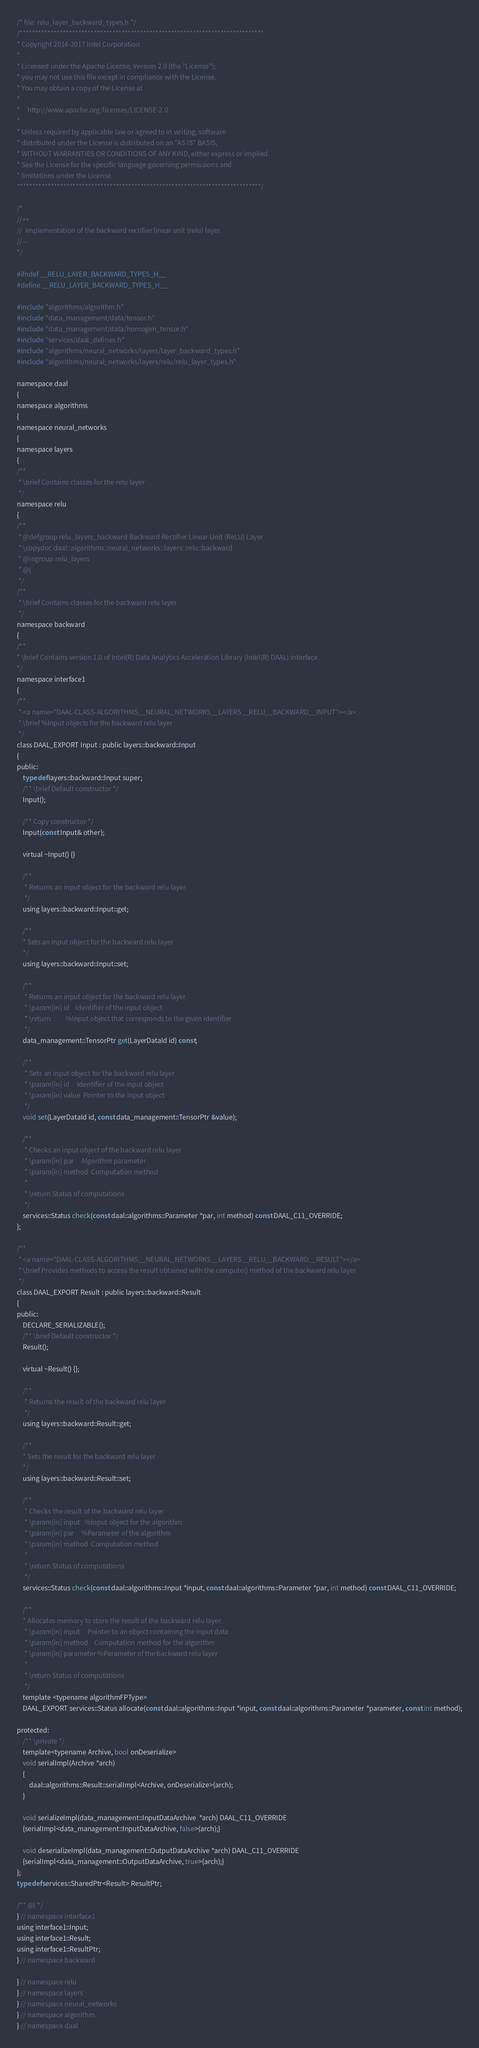<code> <loc_0><loc_0><loc_500><loc_500><_C_>/* file: relu_layer_backward_types.h */
/*******************************************************************************
* Copyright 2014-2017 Intel Corporation
*
* Licensed under the Apache License, Version 2.0 (the "License");
* you may not use this file except in compliance with the License.
* You may obtain a copy of the License at
*
*     http://www.apache.org/licenses/LICENSE-2.0
*
* Unless required by applicable law or agreed to in writing, software
* distributed under the License is distributed on an "AS IS" BASIS,
* WITHOUT WARRANTIES OR CONDITIONS OF ANY KIND, either express or implied.
* See the License for the specific language governing permissions and
* limitations under the License.
*******************************************************************************/

/*
//++
//  Implementation of the backward rectifier linear unit (relu) layer.
//--
*/

#ifndef __RELU_LAYER_BACKWARD_TYPES_H__
#define __RELU_LAYER_BACKWARD_TYPES_H__

#include "algorithms/algorithm.h"
#include "data_management/data/tensor.h"
#include "data_management/data/homogen_tensor.h"
#include "services/daal_defines.h"
#include "algorithms/neural_networks/layers/layer_backward_types.h"
#include "algorithms/neural_networks/layers/relu/relu_layer_types.h"

namespace daal
{
namespace algorithms
{
namespace neural_networks
{
namespace layers
{
/**
 * \brief Contains classes for the relu layer
 */
namespace relu
{
/**
 * @defgroup relu_layers_backward Backward Rectifier Linear Unit (ReLU) Layer
 * \copydoc daal::algorithms::neural_networks::layers::relu::backward
 * @ingroup relu_layers
 * @{
 */
/**
 * \brief Contains classes for the backward relu layer
 */
namespace backward
{
/**
* \brief Contains version 1.0 of Intel(R) Data Analytics Acceleration Library (Intel(R) DAAL) interface.
*/
namespace interface1
{
/**
 * <a name="DAAL-CLASS-ALGORITHMS__NEURAL_NETWORKS__LAYERS__RELU__BACKWARD__INPUT"></a>
 * \brief %Input objects for the backward relu layer
 */
class DAAL_EXPORT Input : public layers::backward::Input
{
public:
    typedef layers::backward::Input super;
    /** \brief Default constructor */
    Input();

    /** Copy constructor */
    Input(const Input& other);

    virtual ~Input() {}

    /**
     * Returns an input object for the backward relu layer
     */
    using layers::backward::Input::get;

    /**
    * Sets an input object for the backward relu layer
    */
    using layers::backward::Input::set;

    /**
     * Returns an input object for the backward relu layer
     * \param[in] id    Identifier of the input object
     * \return          %Input object that corresponds to the given identifier
     */
    data_management::TensorPtr get(LayerDataId id) const;

    /**
     * Sets an input object for the backward relu layer
     * \param[in] id     Identifier of the input object
     * \param[in] value  Pointer to the input object
     */
    void set(LayerDataId id, const data_management::TensorPtr &value);

    /**
     * Checks an input object of the backward relu layer
     * \param[in] par     Algorithm parameter
     * \param[in] method  Computation method
     *
     * \return Status of computations
     */
    services::Status check(const daal::algorithms::Parameter *par, int method) const DAAL_C11_OVERRIDE;
};

/**
 * <a name="DAAL-CLASS-ALGORITHMS__NEURAL_NETWORKS__LAYERS__RELU__BACKWARD__RESULT"></a>
 * \brief Provides methods to access the result obtained with the compute() method of the backward relu layer
 */
class DAAL_EXPORT Result : public layers::backward::Result
{
public:
    DECLARE_SERIALIZABLE();
    /** \brief Default constructor */
    Result();

    virtual ~Result() {};

    /**
     * Returns the result of the backward relu layer
     */
    using layers::backward::Result::get;

    /**
    * Sets the result for the backward relu layer
    */
    using layers::backward::Result::set;

    /**
     * Checks the result of the backward relu layer
     * \param[in] input   %Input object for the algorithm
     * \param[in] par     %Parameter of the algorithm
     * \param[in] method  Computation method
     *
     * \return Status of computations
     */
    services::Status check(const daal::algorithms::Input *input, const daal::algorithms::Parameter *par, int method) const DAAL_C11_OVERRIDE;

    /**
    * Allocates memory to store the result of the backward relu layer
     * \param[in] input     Pointer to an object containing the input data
     * \param[in] method    Computation method for the algorithm
     * \param[in] parameter %Parameter of the backward relu layer
     *
     * \return Status of computations
     */
    template <typename algorithmFPType>
    DAAL_EXPORT services::Status allocate(const daal::algorithms::Input *input, const daal::algorithms::Parameter *parameter, const int method);

protected:
    /** \private */
    template<typename Archive, bool onDeserialize>
    void serialImpl(Archive *arch)
    {
        daal::algorithms::Result::serialImpl<Archive, onDeserialize>(arch);
    }

    void serializeImpl(data_management::InputDataArchive  *arch) DAAL_C11_OVERRIDE
    {serialImpl<data_management::InputDataArchive, false>(arch);}

    void deserializeImpl(data_management::OutputDataArchive *arch) DAAL_C11_OVERRIDE
    {serialImpl<data_management::OutputDataArchive, true>(arch);}
};
typedef services::SharedPtr<Result> ResultPtr;

/** @} */
} // namespace interface1
using interface1::Input;
using interface1::Result;
using interface1::ResultPtr;
} // namespace backward

} // namespace relu
} // namespace layers
} // namespace neural_networks
} // namespace algorithm
} // namespace daal</code> 